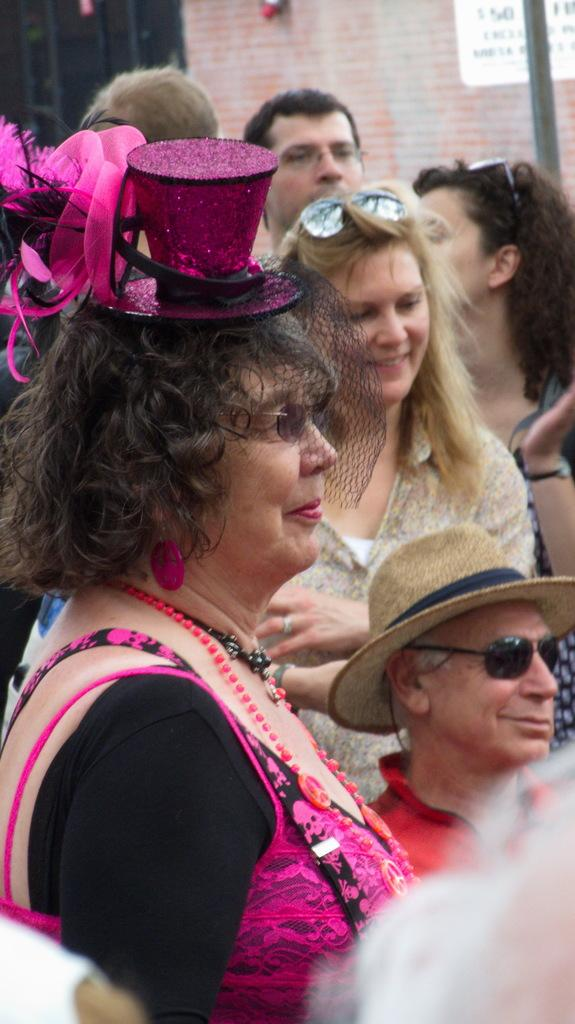How many people are in the image? There are people in the image, but the exact number is not specified. What are some of the people wearing? Some of the people are wearing hats. What can be seen in the image besides the people? There is a pole, a poster with text, a window, and a wall in the image. What type of soup is being served in the image? There is no soup present in the image. What kind of marble is visible in the image? There is no marble visible in the image. 